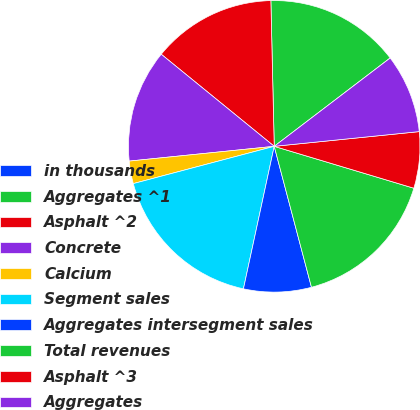Convert chart to OTSL. <chart><loc_0><loc_0><loc_500><loc_500><pie_chart><fcel>in thousands<fcel>Aggregates ^1<fcel>Asphalt ^2<fcel>Concrete<fcel>Calcium<fcel>Segment sales<fcel>Aggregates intersegment sales<fcel>Total revenues<fcel>Asphalt ^3<fcel>Aggregates<nl><fcel>0.01%<fcel>15.0%<fcel>13.75%<fcel>12.5%<fcel>2.5%<fcel>17.5%<fcel>7.5%<fcel>16.25%<fcel>6.25%<fcel>8.75%<nl></chart> 